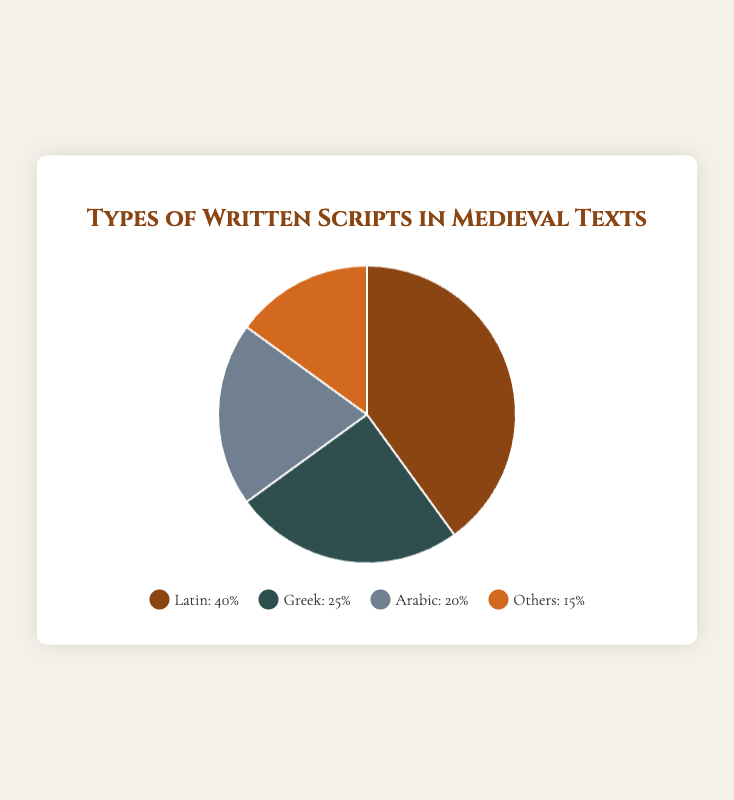What script has the highest percentage of usage in medieval texts? By observing the pie chart, we can see that the section labeled "Latin" occupies the largest segment. The legend confirms that Latin has a percentage value of 40%, which is the highest among the listed categories.
Answer: Latin Which two scripts together account for half of the written scripts in medieval texts? We need to find two segments that together make up 50% of the total. Observing the percentages, "Arabic" accounts for 20% and "Greek" accounts for 25%. Adding these two together gives us 20% + 25% = 45%, which is not 50%. Another combination is "Latin" (40%) and "Others" (15%); 40% + 15% = 55%, which is also not 50%. Therefore, no two scripts alone account for exactly half of the total.
Answer: None What is the difference in percentage between the most and least used scripts? From the pie chart, we see that "Latin" is the most used script at 40%, and "Others" is the least used at 15%. Calculating the difference, we get 40% - 15% = 25%.
Answer: 25% How many scripts together account for 60% or more of the medieval texts? Starting from the highest percentage, "Latin" accounts for 40%. Adding the next highest, "Greek" at 25%, gives us 40% + 25% = 65%. Therefore, two scripts together—Latin and Greek—account for 60% or more.
Answer: 2 Which scripts account for less than a quarter of the total percentage? Observing the pie chart, "Greek" has 25%, "Arabic" has 20%, and "Others" has 15%. Only "Arabic" and "Others" have percentages less than 25%.
Answer: Arabic, Others How much more percentage does Latin account for compared to Arabic? The pie chart shows Latin at 40% and Arabic at 20%. Subtracting Arabic's percentage from Latin's, we get 40% - 20% = 20%.
Answer: 20% If you combine the percentages of Greek and Arabic scripts, how do they compare to the percentage of Latin scripts? "Greek" has 25% and "Arabic" has 20%. Adding these together, we get 25% + 20% = 45%. Comparing this with "Latin" at 40%, 45% is greater than 40%.
Answer: Greek and Arabic combined are greater What segment color represents the "Others" script? The pie chart's legend shows "Others" with a color marker. The visual color for "Others" is a shade of orange.
Answer: Orange 